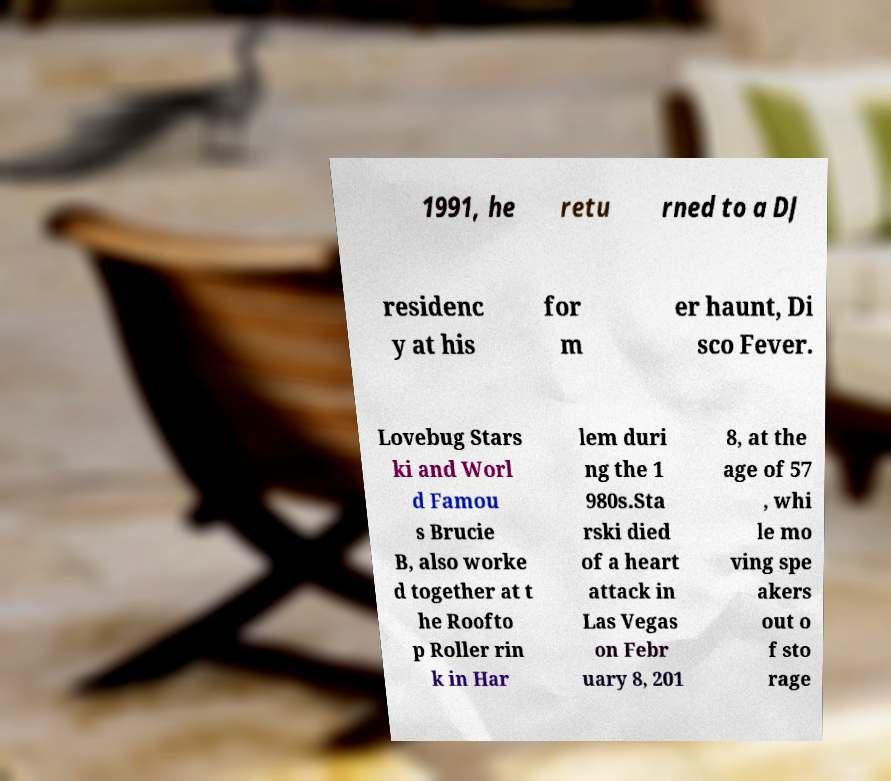Can you accurately transcribe the text from the provided image for me? 1991, he retu rned to a DJ residenc y at his for m er haunt, Di sco Fever. Lovebug Stars ki and Worl d Famou s Brucie B, also worke d together at t he Roofto p Roller rin k in Har lem duri ng the 1 980s.Sta rski died of a heart attack in Las Vegas on Febr uary 8, 201 8, at the age of 57 , whi le mo ving spe akers out o f sto rage 